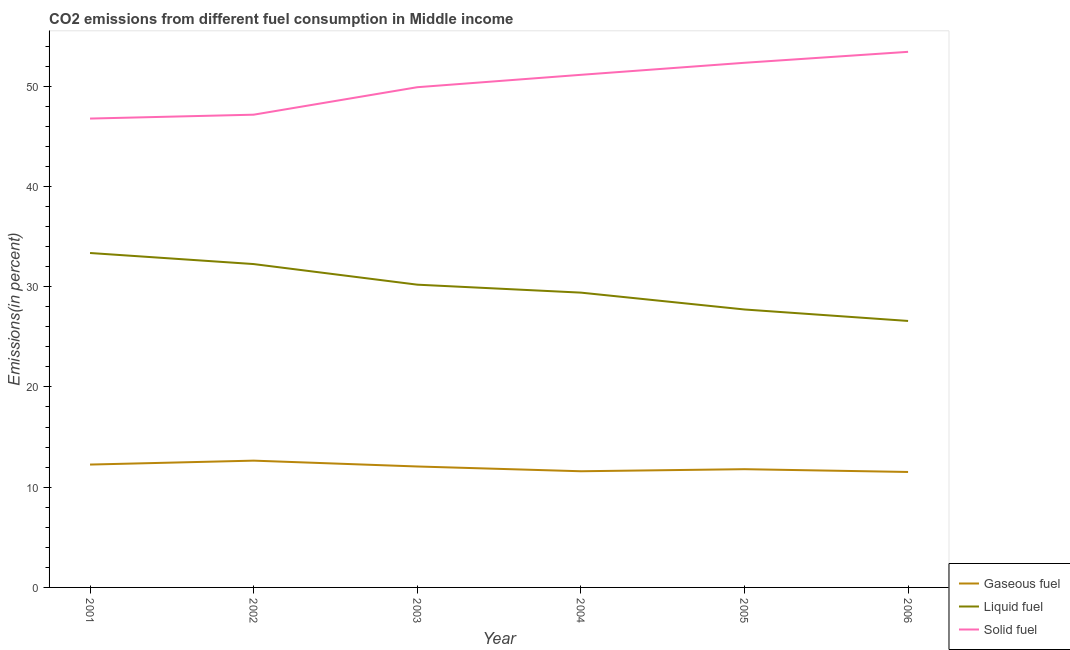What is the percentage of liquid fuel emission in 2006?
Ensure brevity in your answer.  26.58. Across all years, what is the maximum percentage of liquid fuel emission?
Keep it short and to the point. 33.36. Across all years, what is the minimum percentage of gaseous fuel emission?
Provide a short and direct response. 11.52. In which year was the percentage of gaseous fuel emission minimum?
Give a very brief answer. 2006. What is the total percentage of liquid fuel emission in the graph?
Provide a succinct answer. 179.51. What is the difference between the percentage of solid fuel emission in 2002 and that in 2005?
Provide a short and direct response. -5.18. What is the difference between the percentage of liquid fuel emission in 2001 and the percentage of gaseous fuel emission in 2002?
Keep it short and to the point. 20.71. What is the average percentage of solid fuel emission per year?
Provide a short and direct response. 50.11. In the year 2006, what is the difference between the percentage of solid fuel emission and percentage of gaseous fuel emission?
Keep it short and to the point. 41.9. What is the ratio of the percentage of liquid fuel emission in 2004 to that in 2005?
Offer a terse response. 1.06. Is the difference between the percentage of liquid fuel emission in 2002 and 2006 greater than the difference between the percentage of gaseous fuel emission in 2002 and 2006?
Your response must be concise. Yes. What is the difference between the highest and the second highest percentage of gaseous fuel emission?
Provide a short and direct response. 0.39. What is the difference between the highest and the lowest percentage of solid fuel emission?
Your response must be concise. 6.66. Is it the case that in every year, the sum of the percentage of gaseous fuel emission and percentage of liquid fuel emission is greater than the percentage of solid fuel emission?
Offer a terse response. No. Is the percentage of liquid fuel emission strictly less than the percentage of gaseous fuel emission over the years?
Offer a terse response. No. How many lines are there?
Give a very brief answer. 3. How many years are there in the graph?
Provide a succinct answer. 6. Does the graph contain any zero values?
Provide a short and direct response. No. Does the graph contain grids?
Your answer should be compact. No. Where does the legend appear in the graph?
Offer a terse response. Bottom right. How are the legend labels stacked?
Make the answer very short. Vertical. What is the title of the graph?
Your answer should be very brief. CO2 emissions from different fuel consumption in Middle income. What is the label or title of the X-axis?
Your response must be concise. Year. What is the label or title of the Y-axis?
Provide a succinct answer. Emissions(in percent). What is the Emissions(in percent) in Gaseous fuel in 2001?
Provide a short and direct response. 12.25. What is the Emissions(in percent) of Liquid fuel in 2001?
Your answer should be compact. 33.36. What is the Emissions(in percent) in Solid fuel in 2001?
Your response must be concise. 46.76. What is the Emissions(in percent) in Gaseous fuel in 2002?
Make the answer very short. 12.65. What is the Emissions(in percent) of Liquid fuel in 2002?
Your response must be concise. 32.25. What is the Emissions(in percent) in Solid fuel in 2002?
Ensure brevity in your answer.  47.15. What is the Emissions(in percent) of Gaseous fuel in 2003?
Your response must be concise. 12.06. What is the Emissions(in percent) of Liquid fuel in 2003?
Keep it short and to the point. 30.2. What is the Emissions(in percent) in Solid fuel in 2003?
Give a very brief answer. 49.89. What is the Emissions(in percent) of Gaseous fuel in 2004?
Your response must be concise. 11.59. What is the Emissions(in percent) of Liquid fuel in 2004?
Your response must be concise. 29.4. What is the Emissions(in percent) in Solid fuel in 2004?
Provide a succinct answer. 51.13. What is the Emissions(in percent) in Gaseous fuel in 2005?
Give a very brief answer. 11.79. What is the Emissions(in percent) in Liquid fuel in 2005?
Give a very brief answer. 27.72. What is the Emissions(in percent) in Solid fuel in 2005?
Provide a short and direct response. 52.33. What is the Emissions(in percent) of Gaseous fuel in 2006?
Your answer should be compact. 11.52. What is the Emissions(in percent) in Liquid fuel in 2006?
Keep it short and to the point. 26.58. What is the Emissions(in percent) of Solid fuel in 2006?
Provide a succinct answer. 53.42. Across all years, what is the maximum Emissions(in percent) of Gaseous fuel?
Ensure brevity in your answer.  12.65. Across all years, what is the maximum Emissions(in percent) of Liquid fuel?
Offer a very short reply. 33.36. Across all years, what is the maximum Emissions(in percent) of Solid fuel?
Provide a succinct answer. 53.42. Across all years, what is the minimum Emissions(in percent) in Gaseous fuel?
Give a very brief answer. 11.52. Across all years, what is the minimum Emissions(in percent) in Liquid fuel?
Make the answer very short. 26.58. Across all years, what is the minimum Emissions(in percent) in Solid fuel?
Provide a short and direct response. 46.76. What is the total Emissions(in percent) of Gaseous fuel in the graph?
Your answer should be compact. 71.86. What is the total Emissions(in percent) in Liquid fuel in the graph?
Keep it short and to the point. 179.51. What is the total Emissions(in percent) in Solid fuel in the graph?
Offer a very short reply. 300.68. What is the difference between the Emissions(in percent) of Gaseous fuel in 2001 and that in 2002?
Provide a short and direct response. -0.39. What is the difference between the Emissions(in percent) of Liquid fuel in 2001 and that in 2002?
Offer a terse response. 1.1. What is the difference between the Emissions(in percent) in Solid fuel in 2001 and that in 2002?
Offer a very short reply. -0.39. What is the difference between the Emissions(in percent) of Gaseous fuel in 2001 and that in 2003?
Your answer should be compact. 0.19. What is the difference between the Emissions(in percent) in Liquid fuel in 2001 and that in 2003?
Your answer should be compact. 3.16. What is the difference between the Emissions(in percent) of Solid fuel in 2001 and that in 2003?
Your answer should be very brief. -3.13. What is the difference between the Emissions(in percent) of Gaseous fuel in 2001 and that in 2004?
Your response must be concise. 0.67. What is the difference between the Emissions(in percent) of Liquid fuel in 2001 and that in 2004?
Your answer should be very brief. 3.95. What is the difference between the Emissions(in percent) in Solid fuel in 2001 and that in 2004?
Make the answer very short. -4.36. What is the difference between the Emissions(in percent) in Gaseous fuel in 2001 and that in 2005?
Your answer should be compact. 0.46. What is the difference between the Emissions(in percent) of Liquid fuel in 2001 and that in 2005?
Provide a short and direct response. 5.63. What is the difference between the Emissions(in percent) of Solid fuel in 2001 and that in 2005?
Your answer should be very brief. -5.56. What is the difference between the Emissions(in percent) of Gaseous fuel in 2001 and that in 2006?
Your answer should be very brief. 0.74. What is the difference between the Emissions(in percent) in Liquid fuel in 2001 and that in 2006?
Your answer should be compact. 6.78. What is the difference between the Emissions(in percent) of Solid fuel in 2001 and that in 2006?
Give a very brief answer. -6.66. What is the difference between the Emissions(in percent) in Gaseous fuel in 2002 and that in 2003?
Provide a short and direct response. 0.58. What is the difference between the Emissions(in percent) in Liquid fuel in 2002 and that in 2003?
Your answer should be very brief. 2.05. What is the difference between the Emissions(in percent) of Solid fuel in 2002 and that in 2003?
Make the answer very short. -2.74. What is the difference between the Emissions(in percent) in Gaseous fuel in 2002 and that in 2004?
Provide a succinct answer. 1.06. What is the difference between the Emissions(in percent) of Liquid fuel in 2002 and that in 2004?
Offer a terse response. 2.85. What is the difference between the Emissions(in percent) in Solid fuel in 2002 and that in 2004?
Keep it short and to the point. -3.98. What is the difference between the Emissions(in percent) of Gaseous fuel in 2002 and that in 2005?
Keep it short and to the point. 0.85. What is the difference between the Emissions(in percent) of Liquid fuel in 2002 and that in 2005?
Make the answer very short. 4.53. What is the difference between the Emissions(in percent) of Solid fuel in 2002 and that in 2005?
Keep it short and to the point. -5.18. What is the difference between the Emissions(in percent) of Gaseous fuel in 2002 and that in 2006?
Provide a short and direct response. 1.13. What is the difference between the Emissions(in percent) of Liquid fuel in 2002 and that in 2006?
Offer a very short reply. 5.67. What is the difference between the Emissions(in percent) in Solid fuel in 2002 and that in 2006?
Your response must be concise. -6.27. What is the difference between the Emissions(in percent) in Gaseous fuel in 2003 and that in 2004?
Make the answer very short. 0.48. What is the difference between the Emissions(in percent) in Liquid fuel in 2003 and that in 2004?
Your answer should be very brief. 0.79. What is the difference between the Emissions(in percent) of Solid fuel in 2003 and that in 2004?
Make the answer very short. -1.24. What is the difference between the Emissions(in percent) in Gaseous fuel in 2003 and that in 2005?
Ensure brevity in your answer.  0.27. What is the difference between the Emissions(in percent) of Liquid fuel in 2003 and that in 2005?
Your answer should be very brief. 2.48. What is the difference between the Emissions(in percent) in Solid fuel in 2003 and that in 2005?
Your answer should be very brief. -2.44. What is the difference between the Emissions(in percent) of Gaseous fuel in 2003 and that in 2006?
Your response must be concise. 0.55. What is the difference between the Emissions(in percent) in Liquid fuel in 2003 and that in 2006?
Give a very brief answer. 3.62. What is the difference between the Emissions(in percent) in Solid fuel in 2003 and that in 2006?
Give a very brief answer. -3.53. What is the difference between the Emissions(in percent) in Gaseous fuel in 2004 and that in 2005?
Offer a terse response. -0.21. What is the difference between the Emissions(in percent) of Liquid fuel in 2004 and that in 2005?
Keep it short and to the point. 1.68. What is the difference between the Emissions(in percent) in Solid fuel in 2004 and that in 2005?
Offer a terse response. -1.2. What is the difference between the Emissions(in percent) in Gaseous fuel in 2004 and that in 2006?
Offer a very short reply. 0.07. What is the difference between the Emissions(in percent) of Liquid fuel in 2004 and that in 2006?
Your answer should be compact. 2.82. What is the difference between the Emissions(in percent) in Solid fuel in 2004 and that in 2006?
Make the answer very short. -2.29. What is the difference between the Emissions(in percent) in Gaseous fuel in 2005 and that in 2006?
Provide a succinct answer. 0.28. What is the difference between the Emissions(in percent) in Liquid fuel in 2005 and that in 2006?
Give a very brief answer. 1.14. What is the difference between the Emissions(in percent) in Solid fuel in 2005 and that in 2006?
Give a very brief answer. -1.09. What is the difference between the Emissions(in percent) in Gaseous fuel in 2001 and the Emissions(in percent) in Liquid fuel in 2002?
Provide a succinct answer. -20. What is the difference between the Emissions(in percent) in Gaseous fuel in 2001 and the Emissions(in percent) in Solid fuel in 2002?
Make the answer very short. -34.9. What is the difference between the Emissions(in percent) of Liquid fuel in 2001 and the Emissions(in percent) of Solid fuel in 2002?
Ensure brevity in your answer.  -13.79. What is the difference between the Emissions(in percent) in Gaseous fuel in 2001 and the Emissions(in percent) in Liquid fuel in 2003?
Offer a terse response. -17.94. What is the difference between the Emissions(in percent) of Gaseous fuel in 2001 and the Emissions(in percent) of Solid fuel in 2003?
Keep it short and to the point. -37.64. What is the difference between the Emissions(in percent) in Liquid fuel in 2001 and the Emissions(in percent) in Solid fuel in 2003?
Your answer should be very brief. -16.54. What is the difference between the Emissions(in percent) in Gaseous fuel in 2001 and the Emissions(in percent) in Liquid fuel in 2004?
Your answer should be very brief. -17.15. What is the difference between the Emissions(in percent) in Gaseous fuel in 2001 and the Emissions(in percent) in Solid fuel in 2004?
Your answer should be very brief. -38.87. What is the difference between the Emissions(in percent) of Liquid fuel in 2001 and the Emissions(in percent) of Solid fuel in 2004?
Offer a very short reply. -17.77. What is the difference between the Emissions(in percent) of Gaseous fuel in 2001 and the Emissions(in percent) of Liquid fuel in 2005?
Keep it short and to the point. -15.47. What is the difference between the Emissions(in percent) in Gaseous fuel in 2001 and the Emissions(in percent) in Solid fuel in 2005?
Keep it short and to the point. -40.07. What is the difference between the Emissions(in percent) in Liquid fuel in 2001 and the Emissions(in percent) in Solid fuel in 2005?
Give a very brief answer. -18.97. What is the difference between the Emissions(in percent) in Gaseous fuel in 2001 and the Emissions(in percent) in Liquid fuel in 2006?
Offer a very short reply. -14.32. What is the difference between the Emissions(in percent) in Gaseous fuel in 2001 and the Emissions(in percent) in Solid fuel in 2006?
Provide a short and direct response. -41.16. What is the difference between the Emissions(in percent) in Liquid fuel in 2001 and the Emissions(in percent) in Solid fuel in 2006?
Keep it short and to the point. -20.06. What is the difference between the Emissions(in percent) in Gaseous fuel in 2002 and the Emissions(in percent) in Liquid fuel in 2003?
Keep it short and to the point. -17.55. What is the difference between the Emissions(in percent) in Gaseous fuel in 2002 and the Emissions(in percent) in Solid fuel in 2003?
Your answer should be very brief. -37.25. What is the difference between the Emissions(in percent) in Liquid fuel in 2002 and the Emissions(in percent) in Solid fuel in 2003?
Ensure brevity in your answer.  -17.64. What is the difference between the Emissions(in percent) in Gaseous fuel in 2002 and the Emissions(in percent) in Liquid fuel in 2004?
Provide a succinct answer. -16.76. What is the difference between the Emissions(in percent) in Gaseous fuel in 2002 and the Emissions(in percent) in Solid fuel in 2004?
Provide a succinct answer. -38.48. What is the difference between the Emissions(in percent) of Liquid fuel in 2002 and the Emissions(in percent) of Solid fuel in 2004?
Your response must be concise. -18.88. What is the difference between the Emissions(in percent) of Gaseous fuel in 2002 and the Emissions(in percent) of Liquid fuel in 2005?
Offer a very short reply. -15.08. What is the difference between the Emissions(in percent) of Gaseous fuel in 2002 and the Emissions(in percent) of Solid fuel in 2005?
Your answer should be very brief. -39.68. What is the difference between the Emissions(in percent) in Liquid fuel in 2002 and the Emissions(in percent) in Solid fuel in 2005?
Offer a terse response. -20.08. What is the difference between the Emissions(in percent) of Gaseous fuel in 2002 and the Emissions(in percent) of Liquid fuel in 2006?
Your answer should be very brief. -13.93. What is the difference between the Emissions(in percent) in Gaseous fuel in 2002 and the Emissions(in percent) in Solid fuel in 2006?
Your answer should be very brief. -40.77. What is the difference between the Emissions(in percent) in Liquid fuel in 2002 and the Emissions(in percent) in Solid fuel in 2006?
Your answer should be very brief. -21.17. What is the difference between the Emissions(in percent) in Gaseous fuel in 2003 and the Emissions(in percent) in Liquid fuel in 2004?
Provide a succinct answer. -17.34. What is the difference between the Emissions(in percent) in Gaseous fuel in 2003 and the Emissions(in percent) in Solid fuel in 2004?
Offer a very short reply. -39.06. What is the difference between the Emissions(in percent) in Liquid fuel in 2003 and the Emissions(in percent) in Solid fuel in 2004?
Your answer should be compact. -20.93. What is the difference between the Emissions(in percent) in Gaseous fuel in 2003 and the Emissions(in percent) in Liquid fuel in 2005?
Offer a very short reply. -15.66. What is the difference between the Emissions(in percent) in Gaseous fuel in 2003 and the Emissions(in percent) in Solid fuel in 2005?
Offer a very short reply. -40.26. What is the difference between the Emissions(in percent) in Liquid fuel in 2003 and the Emissions(in percent) in Solid fuel in 2005?
Provide a succinct answer. -22.13. What is the difference between the Emissions(in percent) of Gaseous fuel in 2003 and the Emissions(in percent) of Liquid fuel in 2006?
Provide a short and direct response. -14.52. What is the difference between the Emissions(in percent) in Gaseous fuel in 2003 and the Emissions(in percent) in Solid fuel in 2006?
Give a very brief answer. -41.36. What is the difference between the Emissions(in percent) in Liquid fuel in 2003 and the Emissions(in percent) in Solid fuel in 2006?
Your answer should be compact. -23.22. What is the difference between the Emissions(in percent) of Gaseous fuel in 2004 and the Emissions(in percent) of Liquid fuel in 2005?
Offer a terse response. -16.13. What is the difference between the Emissions(in percent) in Gaseous fuel in 2004 and the Emissions(in percent) in Solid fuel in 2005?
Your answer should be very brief. -40.74. What is the difference between the Emissions(in percent) in Liquid fuel in 2004 and the Emissions(in percent) in Solid fuel in 2005?
Make the answer very short. -22.92. What is the difference between the Emissions(in percent) of Gaseous fuel in 2004 and the Emissions(in percent) of Liquid fuel in 2006?
Make the answer very short. -14.99. What is the difference between the Emissions(in percent) of Gaseous fuel in 2004 and the Emissions(in percent) of Solid fuel in 2006?
Provide a short and direct response. -41.83. What is the difference between the Emissions(in percent) in Liquid fuel in 2004 and the Emissions(in percent) in Solid fuel in 2006?
Your answer should be compact. -24.02. What is the difference between the Emissions(in percent) in Gaseous fuel in 2005 and the Emissions(in percent) in Liquid fuel in 2006?
Your response must be concise. -14.79. What is the difference between the Emissions(in percent) in Gaseous fuel in 2005 and the Emissions(in percent) in Solid fuel in 2006?
Offer a terse response. -41.63. What is the difference between the Emissions(in percent) in Liquid fuel in 2005 and the Emissions(in percent) in Solid fuel in 2006?
Your answer should be compact. -25.7. What is the average Emissions(in percent) of Gaseous fuel per year?
Make the answer very short. 11.98. What is the average Emissions(in percent) of Liquid fuel per year?
Your answer should be compact. 29.92. What is the average Emissions(in percent) of Solid fuel per year?
Give a very brief answer. 50.11. In the year 2001, what is the difference between the Emissions(in percent) in Gaseous fuel and Emissions(in percent) in Liquid fuel?
Your answer should be compact. -21.1. In the year 2001, what is the difference between the Emissions(in percent) of Gaseous fuel and Emissions(in percent) of Solid fuel?
Make the answer very short. -34.51. In the year 2001, what is the difference between the Emissions(in percent) of Liquid fuel and Emissions(in percent) of Solid fuel?
Offer a terse response. -13.41. In the year 2002, what is the difference between the Emissions(in percent) in Gaseous fuel and Emissions(in percent) in Liquid fuel?
Give a very brief answer. -19.61. In the year 2002, what is the difference between the Emissions(in percent) in Gaseous fuel and Emissions(in percent) in Solid fuel?
Keep it short and to the point. -34.5. In the year 2002, what is the difference between the Emissions(in percent) in Liquid fuel and Emissions(in percent) in Solid fuel?
Provide a succinct answer. -14.9. In the year 2003, what is the difference between the Emissions(in percent) of Gaseous fuel and Emissions(in percent) of Liquid fuel?
Offer a very short reply. -18.13. In the year 2003, what is the difference between the Emissions(in percent) of Gaseous fuel and Emissions(in percent) of Solid fuel?
Your answer should be very brief. -37.83. In the year 2003, what is the difference between the Emissions(in percent) of Liquid fuel and Emissions(in percent) of Solid fuel?
Your response must be concise. -19.69. In the year 2004, what is the difference between the Emissions(in percent) in Gaseous fuel and Emissions(in percent) in Liquid fuel?
Keep it short and to the point. -17.82. In the year 2004, what is the difference between the Emissions(in percent) in Gaseous fuel and Emissions(in percent) in Solid fuel?
Your answer should be very brief. -39.54. In the year 2004, what is the difference between the Emissions(in percent) of Liquid fuel and Emissions(in percent) of Solid fuel?
Your answer should be compact. -21.72. In the year 2005, what is the difference between the Emissions(in percent) of Gaseous fuel and Emissions(in percent) of Liquid fuel?
Ensure brevity in your answer.  -15.93. In the year 2005, what is the difference between the Emissions(in percent) in Gaseous fuel and Emissions(in percent) in Solid fuel?
Your answer should be compact. -40.53. In the year 2005, what is the difference between the Emissions(in percent) of Liquid fuel and Emissions(in percent) of Solid fuel?
Provide a short and direct response. -24.61. In the year 2006, what is the difference between the Emissions(in percent) of Gaseous fuel and Emissions(in percent) of Liquid fuel?
Make the answer very short. -15.06. In the year 2006, what is the difference between the Emissions(in percent) in Gaseous fuel and Emissions(in percent) in Solid fuel?
Give a very brief answer. -41.9. In the year 2006, what is the difference between the Emissions(in percent) in Liquid fuel and Emissions(in percent) in Solid fuel?
Provide a short and direct response. -26.84. What is the ratio of the Emissions(in percent) of Gaseous fuel in 2001 to that in 2002?
Make the answer very short. 0.97. What is the ratio of the Emissions(in percent) in Liquid fuel in 2001 to that in 2002?
Offer a very short reply. 1.03. What is the ratio of the Emissions(in percent) of Gaseous fuel in 2001 to that in 2003?
Ensure brevity in your answer.  1.02. What is the ratio of the Emissions(in percent) in Liquid fuel in 2001 to that in 2003?
Provide a short and direct response. 1.1. What is the ratio of the Emissions(in percent) of Solid fuel in 2001 to that in 2003?
Make the answer very short. 0.94. What is the ratio of the Emissions(in percent) in Gaseous fuel in 2001 to that in 2004?
Ensure brevity in your answer.  1.06. What is the ratio of the Emissions(in percent) in Liquid fuel in 2001 to that in 2004?
Offer a very short reply. 1.13. What is the ratio of the Emissions(in percent) of Solid fuel in 2001 to that in 2004?
Offer a very short reply. 0.91. What is the ratio of the Emissions(in percent) of Gaseous fuel in 2001 to that in 2005?
Ensure brevity in your answer.  1.04. What is the ratio of the Emissions(in percent) in Liquid fuel in 2001 to that in 2005?
Provide a short and direct response. 1.2. What is the ratio of the Emissions(in percent) of Solid fuel in 2001 to that in 2005?
Give a very brief answer. 0.89. What is the ratio of the Emissions(in percent) of Gaseous fuel in 2001 to that in 2006?
Give a very brief answer. 1.06. What is the ratio of the Emissions(in percent) in Liquid fuel in 2001 to that in 2006?
Offer a very short reply. 1.25. What is the ratio of the Emissions(in percent) in Solid fuel in 2001 to that in 2006?
Give a very brief answer. 0.88. What is the ratio of the Emissions(in percent) in Gaseous fuel in 2002 to that in 2003?
Keep it short and to the point. 1.05. What is the ratio of the Emissions(in percent) of Liquid fuel in 2002 to that in 2003?
Offer a very short reply. 1.07. What is the ratio of the Emissions(in percent) of Solid fuel in 2002 to that in 2003?
Offer a very short reply. 0.95. What is the ratio of the Emissions(in percent) in Gaseous fuel in 2002 to that in 2004?
Make the answer very short. 1.09. What is the ratio of the Emissions(in percent) of Liquid fuel in 2002 to that in 2004?
Your answer should be compact. 1.1. What is the ratio of the Emissions(in percent) of Solid fuel in 2002 to that in 2004?
Ensure brevity in your answer.  0.92. What is the ratio of the Emissions(in percent) of Gaseous fuel in 2002 to that in 2005?
Give a very brief answer. 1.07. What is the ratio of the Emissions(in percent) of Liquid fuel in 2002 to that in 2005?
Your answer should be very brief. 1.16. What is the ratio of the Emissions(in percent) in Solid fuel in 2002 to that in 2005?
Provide a succinct answer. 0.9. What is the ratio of the Emissions(in percent) in Gaseous fuel in 2002 to that in 2006?
Ensure brevity in your answer.  1.1. What is the ratio of the Emissions(in percent) in Liquid fuel in 2002 to that in 2006?
Your response must be concise. 1.21. What is the ratio of the Emissions(in percent) of Solid fuel in 2002 to that in 2006?
Your answer should be very brief. 0.88. What is the ratio of the Emissions(in percent) of Gaseous fuel in 2003 to that in 2004?
Provide a succinct answer. 1.04. What is the ratio of the Emissions(in percent) in Liquid fuel in 2003 to that in 2004?
Offer a very short reply. 1.03. What is the ratio of the Emissions(in percent) in Solid fuel in 2003 to that in 2004?
Provide a succinct answer. 0.98. What is the ratio of the Emissions(in percent) in Gaseous fuel in 2003 to that in 2005?
Provide a short and direct response. 1.02. What is the ratio of the Emissions(in percent) in Liquid fuel in 2003 to that in 2005?
Keep it short and to the point. 1.09. What is the ratio of the Emissions(in percent) of Solid fuel in 2003 to that in 2005?
Your answer should be very brief. 0.95. What is the ratio of the Emissions(in percent) of Gaseous fuel in 2003 to that in 2006?
Offer a very short reply. 1.05. What is the ratio of the Emissions(in percent) of Liquid fuel in 2003 to that in 2006?
Keep it short and to the point. 1.14. What is the ratio of the Emissions(in percent) in Solid fuel in 2003 to that in 2006?
Give a very brief answer. 0.93. What is the ratio of the Emissions(in percent) of Gaseous fuel in 2004 to that in 2005?
Make the answer very short. 0.98. What is the ratio of the Emissions(in percent) in Liquid fuel in 2004 to that in 2005?
Provide a short and direct response. 1.06. What is the ratio of the Emissions(in percent) in Solid fuel in 2004 to that in 2005?
Provide a short and direct response. 0.98. What is the ratio of the Emissions(in percent) of Gaseous fuel in 2004 to that in 2006?
Provide a succinct answer. 1.01. What is the ratio of the Emissions(in percent) in Liquid fuel in 2004 to that in 2006?
Provide a short and direct response. 1.11. What is the ratio of the Emissions(in percent) of Solid fuel in 2004 to that in 2006?
Your answer should be very brief. 0.96. What is the ratio of the Emissions(in percent) of Gaseous fuel in 2005 to that in 2006?
Make the answer very short. 1.02. What is the ratio of the Emissions(in percent) of Liquid fuel in 2005 to that in 2006?
Offer a terse response. 1.04. What is the ratio of the Emissions(in percent) of Solid fuel in 2005 to that in 2006?
Offer a terse response. 0.98. What is the difference between the highest and the second highest Emissions(in percent) of Gaseous fuel?
Offer a terse response. 0.39. What is the difference between the highest and the second highest Emissions(in percent) of Liquid fuel?
Your answer should be compact. 1.1. What is the difference between the highest and the second highest Emissions(in percent) in Solid fuel?
Offer a terse response. 1.09. What is the difference between the highest and the lowest Emissions(in percent) in Gaseous fuel?
Offer a very short reply. 1.13. What is the difference between the highest and the lowest Emissions(in percent) in Liquid fuel?
Make the answer very short. 6.78. What is the difference between the highest and the lowest Emissions(in percent) in Solid fuel?
Ensure brevity in your answer.  6.66. 